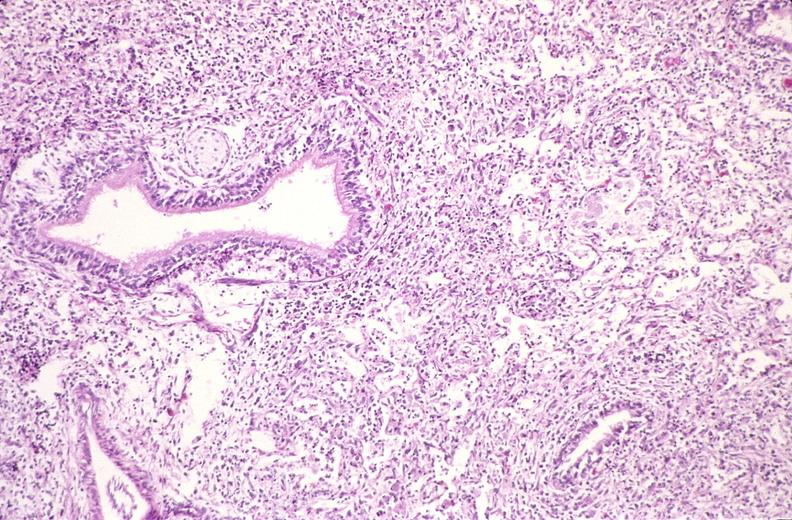what is present?
Answer the question using a single word or phrase. Respiratory 